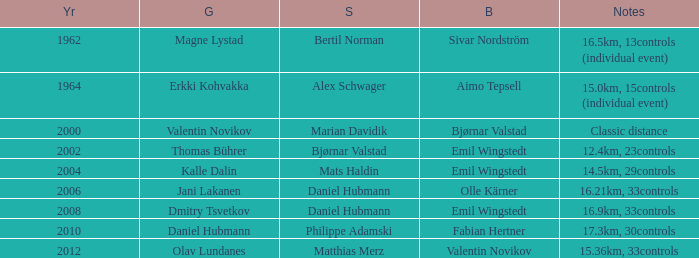What is the silver originating in 1962? Bertil Norman. 